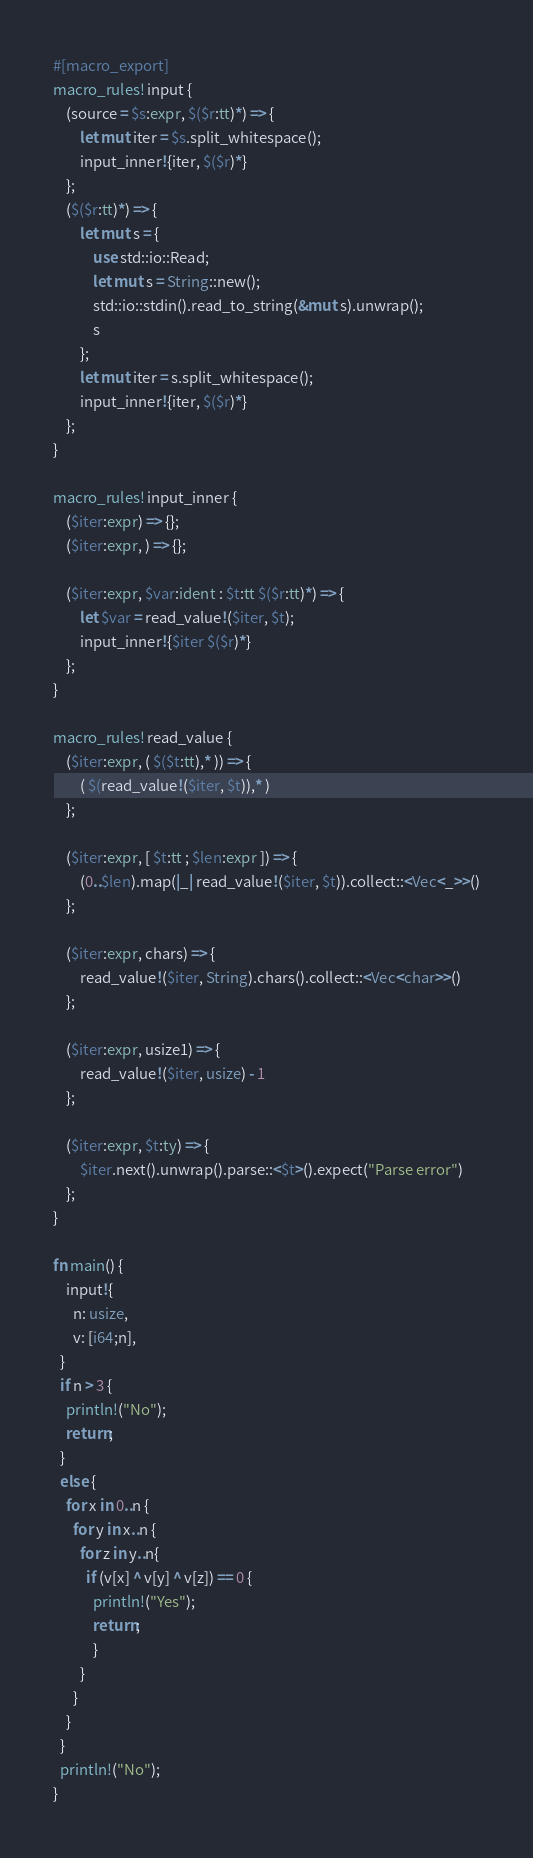Convert code to text. <code><loc_0><loc_0><loc_500><loc_500><_Rust_>#[macro_export]
macro_rules! input {
    (source = $s:expr, $($r:tt)*) => {
        let mut iter = $s.split_whitespace();
        input_inner!{iter, $($r)*}
    };
    ($($r:tt)*) => {
        let mut s = {
            use std::io::Read;
            let mut s = String::new();
            std::io::stdin().read_to_string(&mut s).unwrap();
            s
        };
        let mut iter = s.split_whitespace();
        input_inner!{iter, $($r)*}
    };
}

macro_rules! input_inner {
    ($iter:expr) => {};
    ($iter:expr, ) => {};

    ($iter:expr, $var:ident : $t:tt $($r:tt)*) => {
        let $var = read_value!($iter, $t);
        input_inner!{$iter $($r)*}
    };
}

macro_rules! read_value {
    ($iter:expr, ( $($t:tt),* )) => {
        ( $(read_value!($iter, $t)),* )
    };

    ($iter:expr, [ $t:tt ; $len:expr ]) => {
        (0..$len).map(|_| read_value!($iter, $t)).collect::<Vec<_>>()
    };

    ($iter:expr, chars) => {
        read_value!($iter, String).chars().collect::<Vec<char>>()
    };

    ($iter:expr, usize1) => {
        read_value!($iter, usize) - 1
    };

    ($iter:expr, $t:ty) => {
        $iter.next().unwrap().parse::<$t>().expect("Parse error")
    };
}

fn main() {
    input!{
      n: usize,
      v: [i64;n],
  }
  if n > 3 {
    println!("No");
    return;
  }
  else {
    for x in 0..n {
      for y in x..n {
        for z in y..n{
          if (v[x] ^ v[y] ^ v[z]) == 0 { 
            println!("Yes");
            return;
            }
        }
      }
    }
  }
  println!("No");
}</code> 